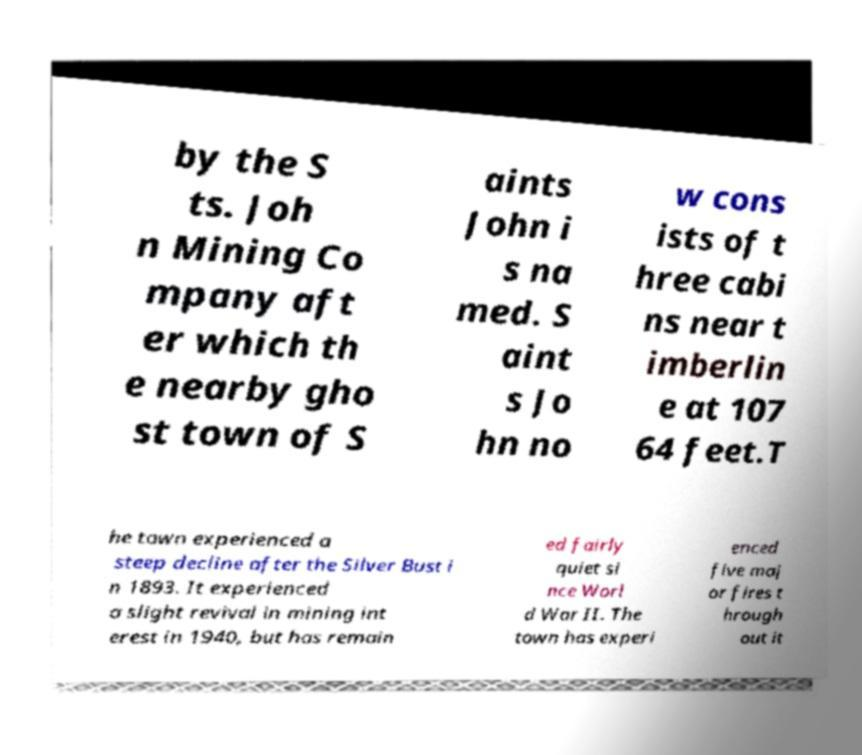Could you extract and type out the text from this image? by the S ts. Joh n Mining Co mpany aft er which th e nearby gho st town of S aints John i s na med. S aint s Jo hn no w cons ists of t hree cabi ns near t imberlin e at 107 64 feet.T he town experienced a steep decline after the Silver Bust i n 1893. It experienced a slight revival in mining int erest in 1940, but has remain ed fairly quiet si nce Worl d War II. The town has experi enced five maj or fires t hrough out it 